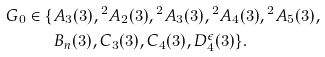Convert formula to latex. <formula><loc_0><loc_0><loc_500><loc_500>G _ { 0 } \in \{ & A _ { 3 } ( 3 ) , { ^ { 2 } } A _ { 2 } ( 3 ) , { ^ { 2 } } A _ { 3 } ( 3 ) , { ^ { 2 } } A _ { 4 } ( 3 ) , { ^ { 2 } } A _ { 5 } ( 3 ) , \\ & B _ { n } ( 3 ) , C _ { 3 } ( 3 ) , C _ { 4 } ( 3 ) , D _ { 4 } ^ { \epsilon } ( 3 ) \} .</formula> 